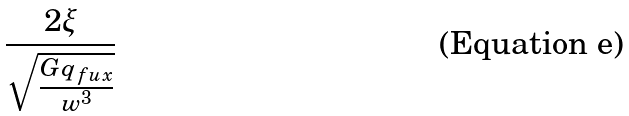Convert formula to latex. <formula><loc_0><loc_0><loc_500><loc_500>\frac { 2 \xi } { \sqrt { \frac { G q _ { f u x } } { w ^ { 3 } } } }</formula> 